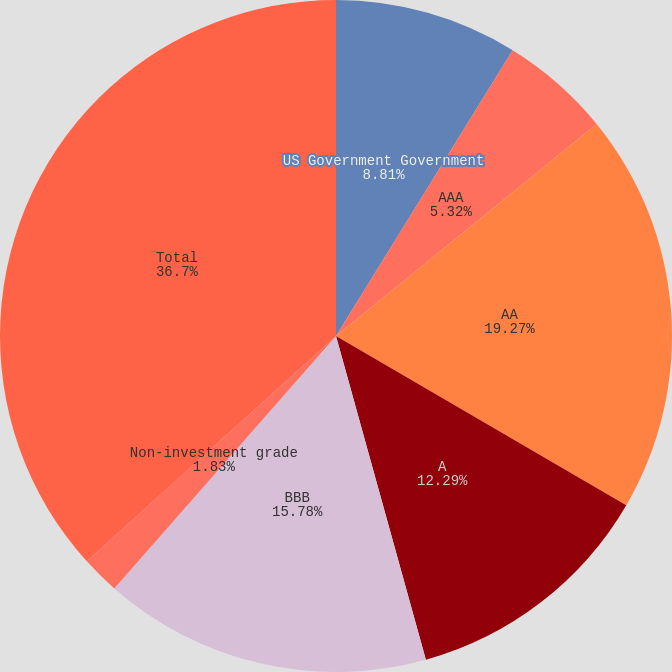<chart> <loc_0><loc_0><loc_500><loc_500><pie_chart><fcel>US Government Government<fcel>AAA<fcel>AA<fcel>A<fcel>BBB<fcel>Non-investment grade<fcel>Total<nl><fcel>8.81%<fcel>5.32%<fcel>19.27%<fcel>12.29%<fcel>15.78%<fcel>1.83%<fcel>36.7%<nl></chart> 